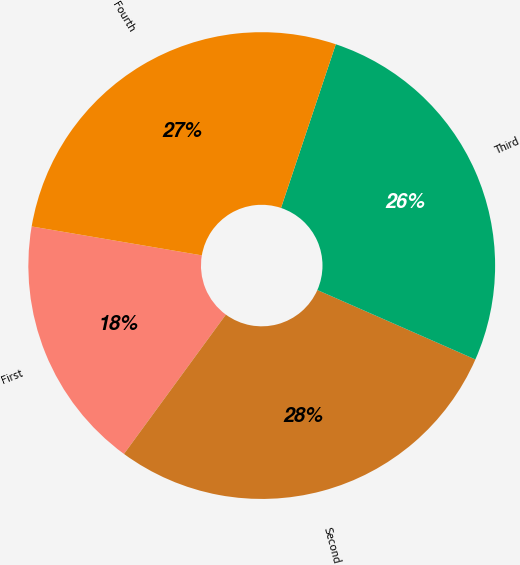Convert chart. <chart><loc_0><loc_0><loc_500><loc_500><pie_chart><fcel>First<fcel>Second<fcel>Third<fcel>Fourth<nl><fcel>17.63%<fcel>28.46%<fcel>26.45%<fcel>27.46%<nl></chart> 